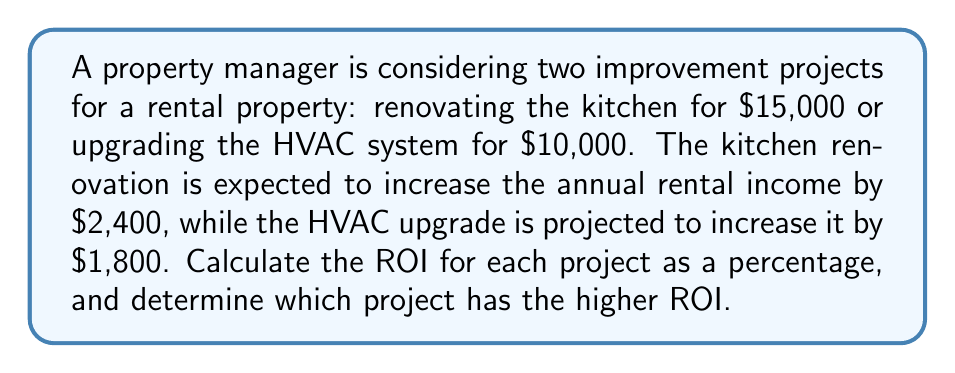Can you answer this question? To calculate the Return on Investment (ROI) for each project, we'll use the formula:

$$ ROI = \frac{\text{Annual Increase in Income}}{\text{Cost of Investment}} \times 100\% $$

1. Kitchen Renovation ROI:
   - Cost: $15,000
   - Annual Increase in Income: $2,400
   $$ ROI_{kitchen} = \frac{2,400}{15,000} \times 100\% = 0.16 \times 100\% = 16\% $$

2. HVAC Upgrade ROI:
   - Cost: $10,000
   - Annual Increase in Income: $1,800
   $$ ROI_{HVAC} = \frac{1,800}{10,000} \times 100\% = 0.18 \times 100\% = 18\% $$

Comparing the two ROIs:
$ROI_{HVAC} (18\%) > ROI_{kitchen} (16\%)$

Therefore, the HVAC upgrade has a higher ROI.
Answer: HVAC upgrade: 18% ROI (higher) 